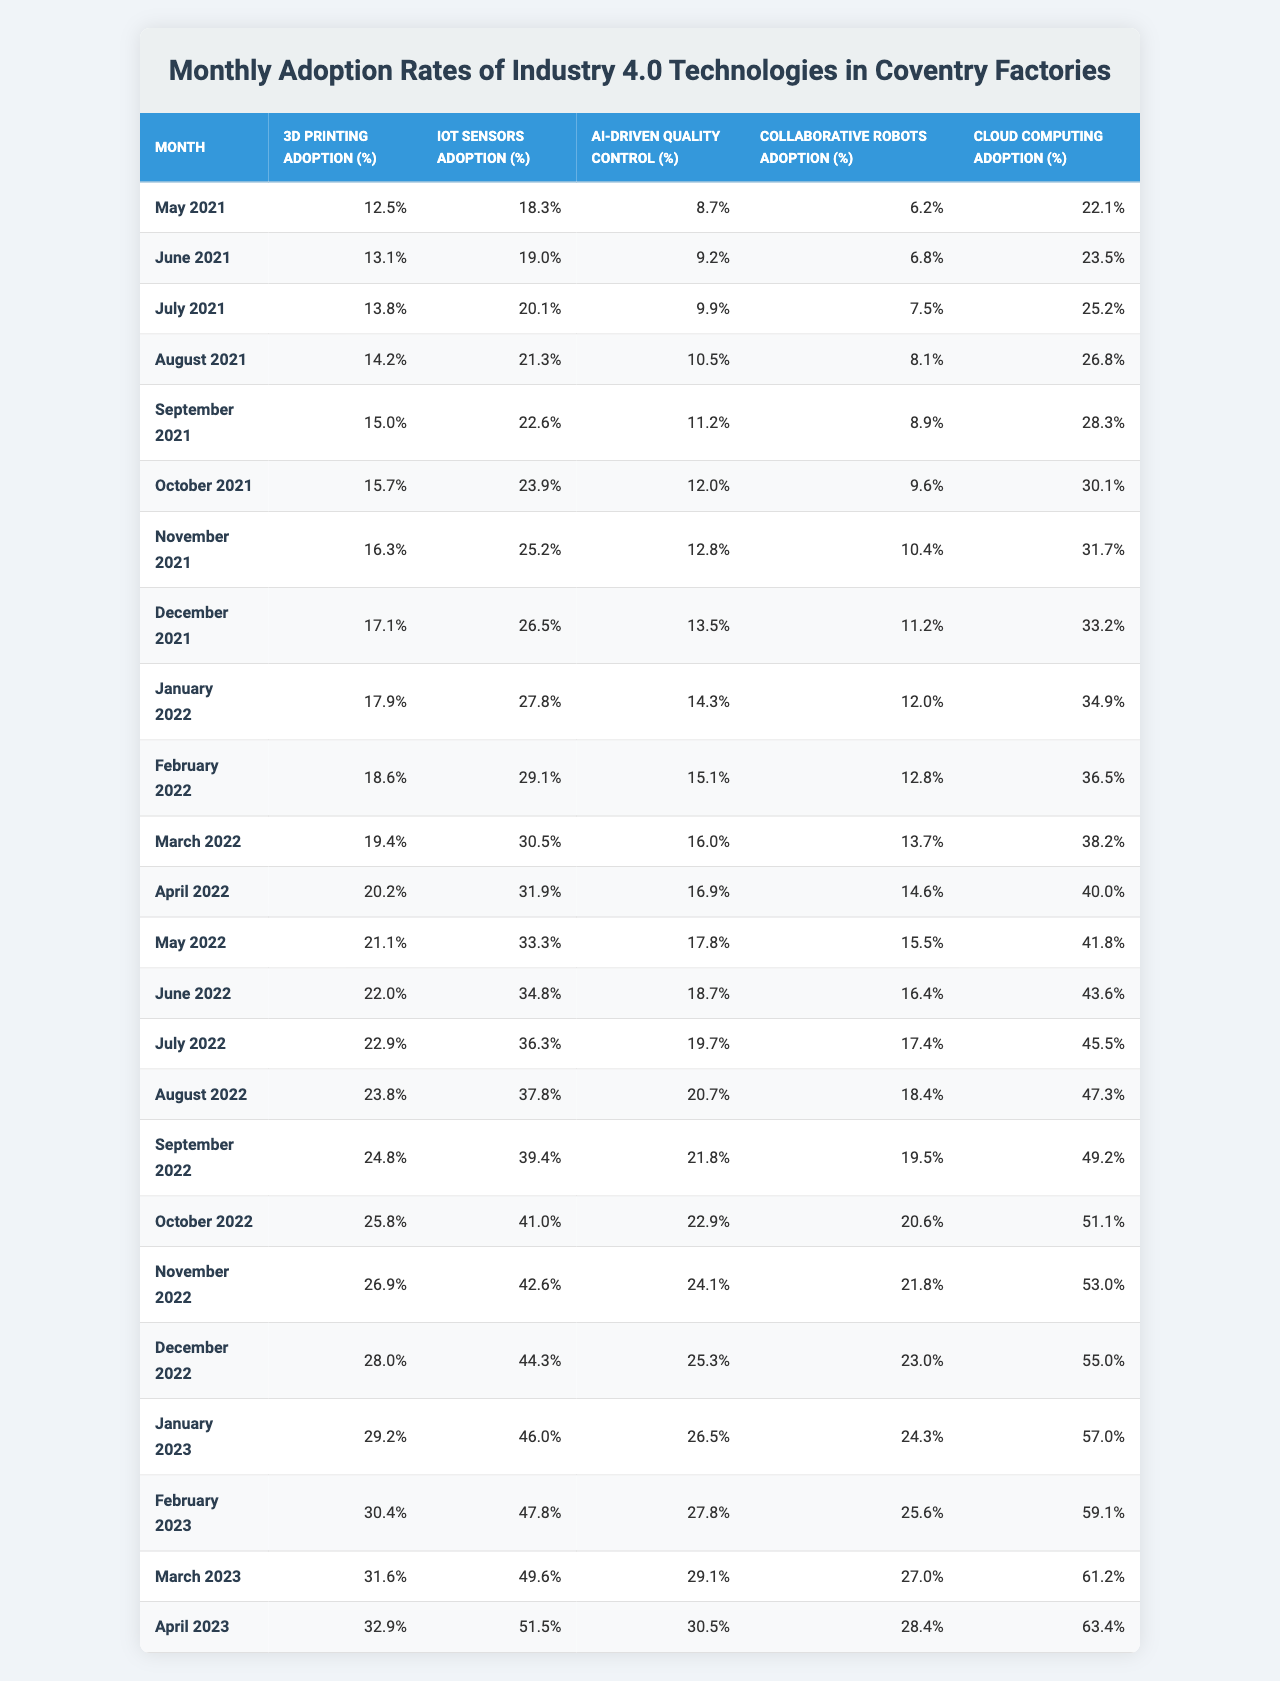What was the adoption rate of IoT sensors in December 2022? In December 2022, the percentage of IoT sensors adoption is listed directly in the table as 44.3%.
Answer: 44.3% Which technology had the highest adoption rate in April 2023? In April 2023, I can compare the adoption rates from the table: 3D Printing (32.9%), IoT Sensors (51.5%), AI-driven Quality Control (30.5%), Collaborative Robots (28.4%), and Cloud Computing (63.4%). Cloud Computing has the highest value of 63.4%.
Answer: Cloud Computing What is the difference between the adoption rates of 3D Printing in January 2022 and January 2023? The adoption rate for 3D Printing in January 2022 is 17.9% and in January 2023 is 29.2%. The difference is calculated as 29.2% - 17.9% = 11.3%.
Answer: 11.3% What was the average adoption rate of AI-driven Quality Control over the last 24 months? To find the average, I need to add all the values for AI-driven Quality Control over the 24 months and then divide by 24. The sum of the values (8.7 + 9.2 + 9.9 + ... + 30.5) is 543.7. Dividing that by 24 gives approximately 22.4%.
Answer: 22.4% Is the adoption rate of Collaborative Robots greater than 20% in October 2022? In October 2022, the adoption rate for Collaborative Robots is listed as 20.6%. Since 20.6% is greater than 20%, the answer is yes.
Answer: Yes What trend can be observed in the adoption rates of Cloud Computing from May 2021 to April 2023? By examining the table from May 2021 to April 2023, I see that the adoption rate of Cloud Computing has increased from 22.1% to 63.4%, indicating a steady upward trend over the 24 months.
Answer: Steady upward trend In which month did the adoption rate of 3D Printing first exceed 25%? Looking through the table, the first month where the adoption rate of 3D Printing exceeded 25% is October 2022, where it reached 25.8%.
Answer: October 2022 How much did the adoption rate of IoT Sensors increase from May 2021 to April 2023? The adoption rate of IoT Sensors in May 2021 is 18.3%, and in April 2023, it is 51.5%. The increase is calculated as 51.5% - 18.3% = 33.2%.
Answer: 33.2% What was the highest recorded adoption rate for AI-driven Quality Control and in which month did it occur? From the table, the highest adoption rate for AI-driven Quality Control is 30.5% which occurred in April 2023.
Answer: 30.5% in April 2023 Is it true that the adoption rate of Cloud Computing was consistently above 50% in 2023? Referring to the table, the adoption rates for Cloud Computing in 2023 are 57.0% in January, 59.1% in February, 61.2% in March, and 63.4% in April. Since all these values are above 50%, the statement is true.
Answer: True 